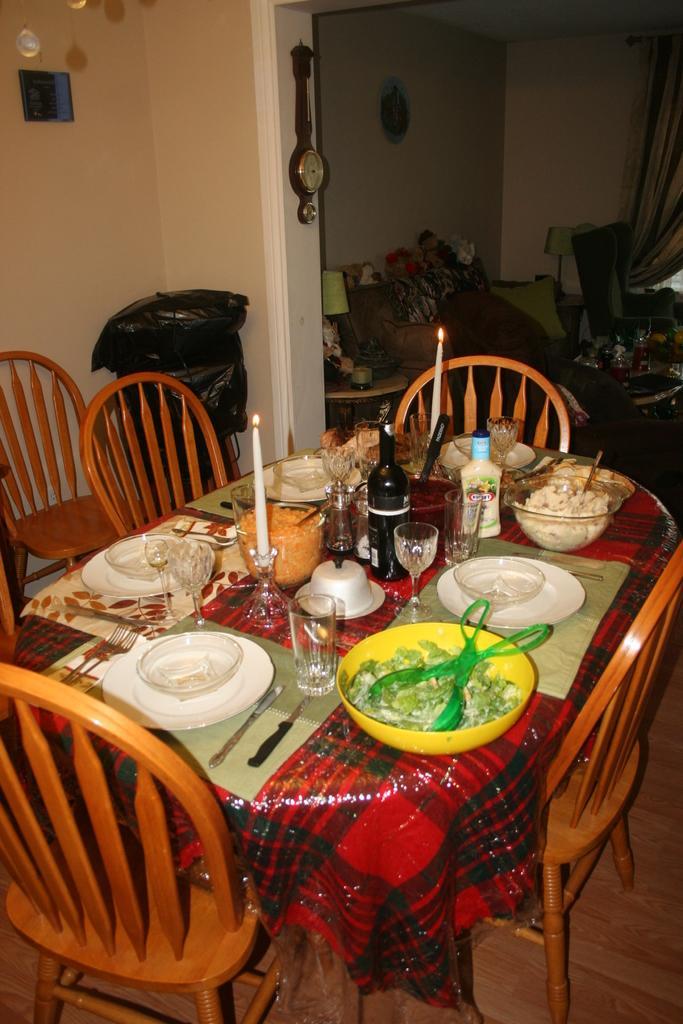How would you summarize this image in a sentence or two? In this image there is a table and we can see bowls, glasses, bottles, candles, knife, spoons and some food placed on the table. We can see chairs. In the background there is a wall and we can see a curtain. There is a sofa and we can see lamps. There are decors placed on the wall. 